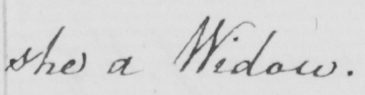What is written in this line of handwriting? she a Widow . 